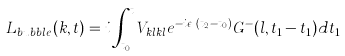<formula> <loc_0><loc_0><loc_500><loc_500>L _ { b u b b l e } ( k , t ) = i \int _ { t _ { 0 } } ^ { t } V _ { k l k l } e ^ { - i \epsilon _ { k } ( t _ { 2 } - t _ { 0 } ) } G ^ { - } ( l , t _ { 1 } - t _ { 1 } ) d t _ { 1 }</formula> 